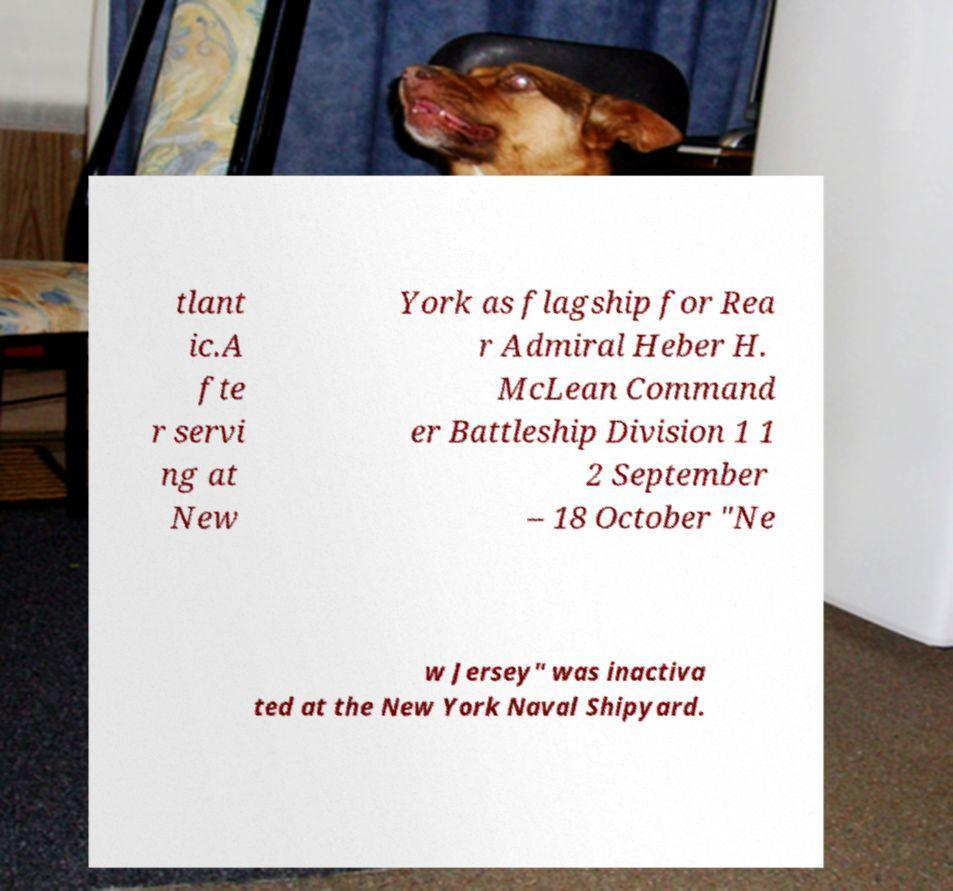For documentation purposes, I need the text within this image transcribed. Could you provide that? tlant ic.A fte r servi ng at New York as flagship for Rea r Admiral Heber H. McLean Command er Battleship Division 1 1 2 September – 18 October "Ne w Jersey" was inactiva ted at the New York Naval Shipyard. 